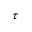Convert formula to latex. <formula><loc_0><loc_0><loc_500><loc_500>\tau</formula> 